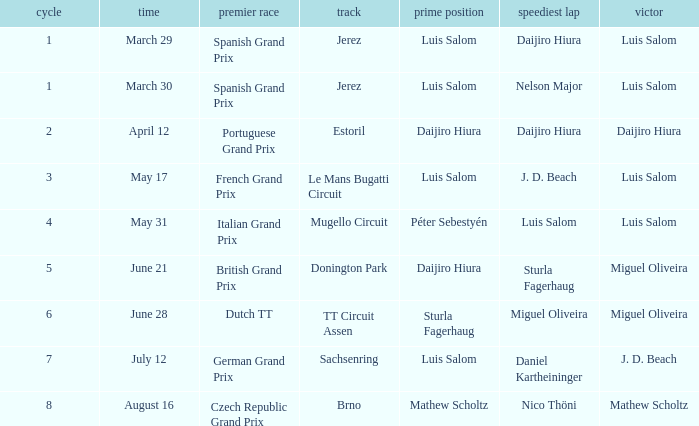What grand prixs did Daijiro Hiura win?  Portuguese Grand Prix. 